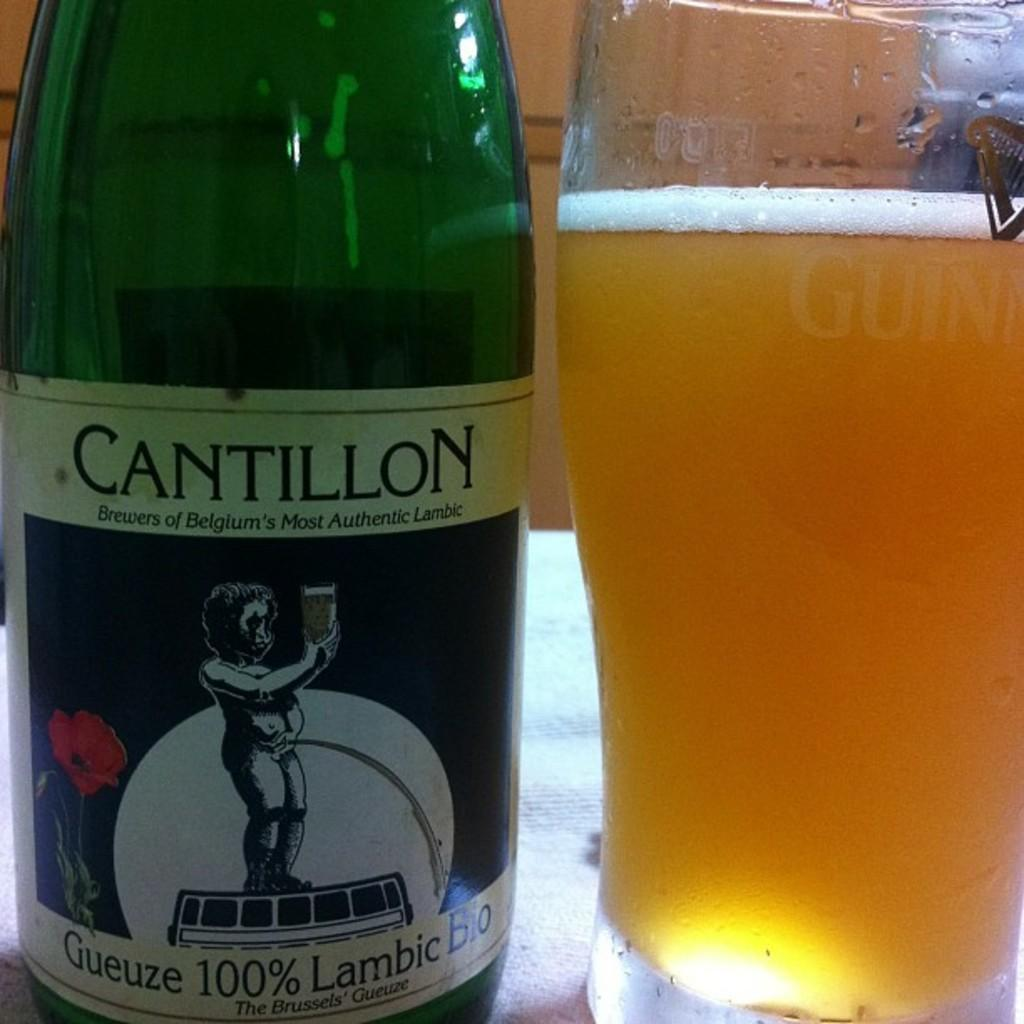<image>
Render a clear and concise summary of the photo. A bottle of Cantillon is placed next to a Guinness glass. 